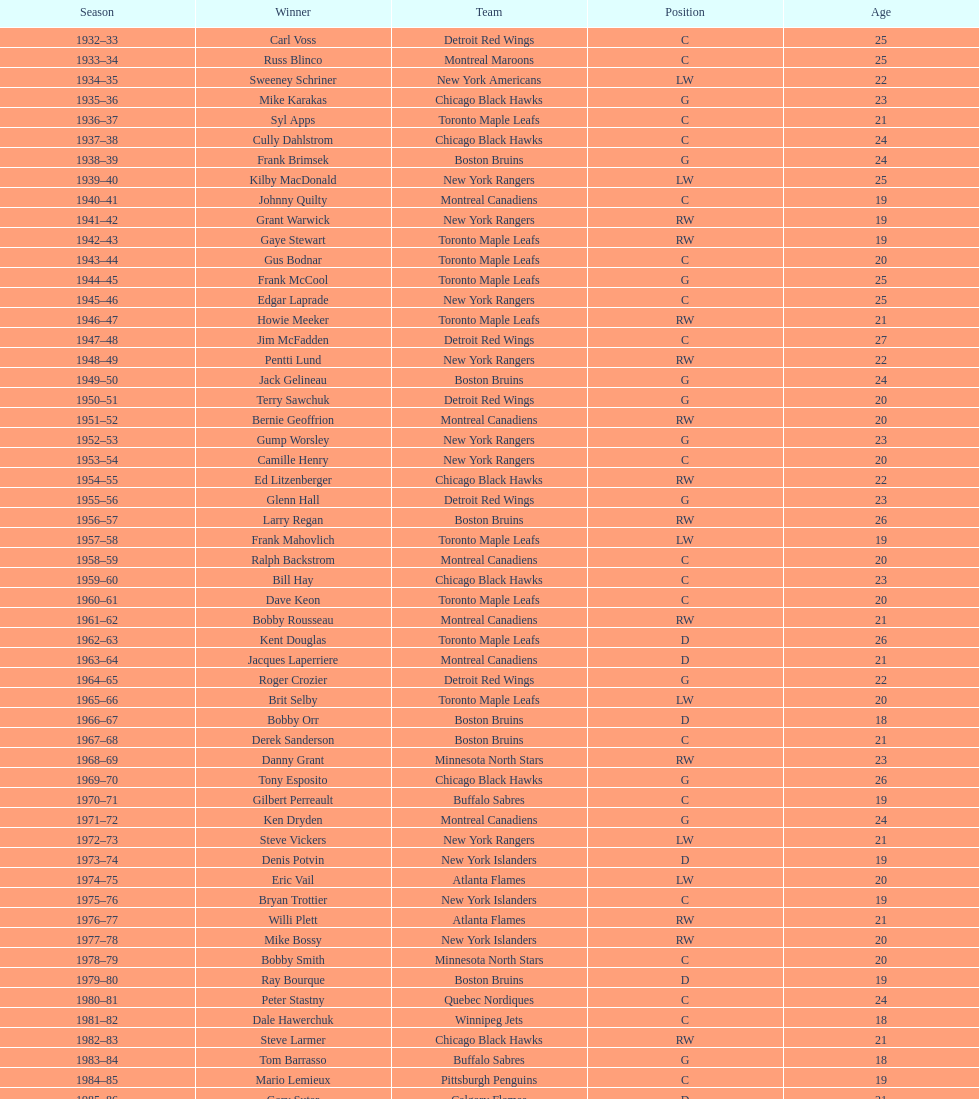Could you parse the entire table as a dict? {'header': ['Season', 'Winner', 'Team', 'Position', 'Age'], 'rows': [['1932–33', 'Carl Voss', 'Detroit Red Wings', 'C', '25'], ['1933–34', 'Russ Blinco', 'Montreal Maroons', 'C', '25'], ['1934–35', 'Sweeney Schriner', 'New York Americans', 'LW', '22'], ['1935–36', 'Mike Karakas', 'Chicago Black Hawks', 'G', '23'], ['1936–37', 'Syl Apps', 'Toronto Maple Leafs', 'C', '21'], ['1937–38', 'Cully Dahlstrom', 'Chicago Black Hawks', 'C', '24'], ['1938–39', 'Frank Brimsek', 'Boston Bruins', 'G', '24'], ['1939–40', 'Kilby MacDonald', 'New York Rangers', 'LW', '25'], ['1940–41', 'Johnny Quilty', 'Montreal Canadiens', 'C', '19'], ['1941–42', 'Grant Warwick', 'New York Rangers', 'RW', '19'], ['1942–43', 'Gaye Stewart', 'Toronto Maple Leafs', 'RW', '19'], ['1943–44', 'Gus Bodnar', 'Toronto Maple Leafs', 'C', '20'], ['1944–45', 'Frank McCool', 'Toronto Maple Leafs', 'G', '25'], ['1945–46', 'Edgar Laprade', 'New York Rangers', 'C', '25'], ['1946–47', 'Howie Meeker', 'Toronto Maple Leafs', 'RW', '21'], ['1947–48', 'Jim McFadden', 'Detroit Red Wings', 'C', '27'], ['1948–49', 'Pentti Lund', 'New York Rangers', 'RW', '22'], ['1949–50', 'Jack Gelineau', 'Boston Bruins', 'G', '24'], ['1950–51', 'Terry Sawchuk', 'Detroit Red Wings', 'G', '20'], ['1951–52', 'Bernie Geoffrion', 'Montreal Canadiens', 'RW', '20'], ['1952–53', 'Gump Worsley', 'New York Rangers', 'G', '23'], ['1953–54', 'Camille Henry', 'New York Rangers', 'C', '20'], ['1954–55', 'Ed Litzenberger', 'Chicago Black Hawks', 'RW', '22'], ['1955–56', 'Glenn Hall', 'Detroit Red Wings', 'G', '23'], ['1956–57', 'Larry Regan', 'Boston Bruins', 'RW', '26'], ['1957–58', 'Frank Mahovlich', 'Toronto Maple Leafs', 'LW', '19'], ['1958–59', 'Ralph Backstrom', 'Montreal Canadiens', 'C', '20'], ['1959–60', 'Bill Hay', 'Chicago Black Hawks', 'C', '23'], ['1960–61', 'Dave Keon', 'Toronto Maple Leafs', 'C', '20'], ['1961–62', 'Bobby Rousseau', 'Montreal Canadiens', 'RW', '21'], ['1962–63', 'Kent Douglas', 'Toronto Maple Leafs', 'D', '26'], ['1963–64', 'Jacques Laperriere', 'Montreal Canadiens', 'D', '21'], ['1964–65', 'Roger Crozier', 'Detroit Red Wings', 'G', '22'], ['1965–66', 'Brit Selby', 'Toronto Maple Leafs', 'LW', '20'], ['1966–67', 'Bobby Orr', 'Boston Bruins', 'D', '18'], ['1967–68', 'Derek Sanderson', 'Boston Bruins', 'C', '21'], ['1968–69', 'Danny Grant', 'Minnesota North Stars', 'RW', '23'], ['1969–70', 'Tony Esposito', 'Chicago Black Hawks', 'G', '26'], ['1970–71', 'Gilbert Perreault', 'Buffalo Sabres', 'C', '19'], ['1971–72', 'Ken Dryden', 'Montreal Canadiens', 'G', '24'], ['1972–73', 'Steve Vickers', 'New York Rangers', 'LW', '21'], ['1973–74', 'Denis Potvin', 'New York Islanders', 'D', '19'], ['1974–75', 'Eric Vail', 'Atlanta Flames', 'LW', '20'], ['1975–76', 'Bryan Trottier', 'New York Islanders', 'C', '19'], ['1976–77', 'Willi Plett', 'Atlanta Flames', 'RW', '21'], ['1977–78', 'Mike Bossy', 'New York Islanders', 'RW', '20'], ['1978–79', 'Bobby Smith', 'Minnesota North Stars', 'C', '20'], ['1979–80', 'Ray Bourque', 'Boston Bruins', 'D', '19'], ['1980–81', 'Peter Stastny', 'Quebec Nordiques', 'C', '24'], ['1981–82', 'Dale Hawerchuk', 'Winnipeg Jets', 'C', '18'], ['1982–83', 'Steve Larmer', 'Chicago Black Hawks', 'RW', '21'], ['1983–84', 'Tom Barrasso', 'Buffalo Sabres', 'G', '18'], ['1984–85', 'Mario Lemieux', 'Pittsburgh Penguins', 'C', '19'], ['1985–86', 'Gary Suter', 'Calgary Flames', 'D', '21'], ['1986–87', 'Luc Robitaille', 'Los Angeles Kings', 'LW', '20'], ['1987–88', 'Joe Nieuwendyk', 'Calgary Flames', 'C', '21'], ['1988–89', 'Brian Leetch', 'New York Rangers', 'D', '20'], ['1989–90', 'Sergei Makarov', 'Calgary Flames', 'RW', '31'], ['1990–91', 'Ed Belfour', 'Chicago Blackhawks', 'G', '25'], ['1991–92', 'Pavel Bure', 'Vancouver Canucks', 'RW', '20'], ['1992–93', 'Teemu Selanne', 'Winnipeg Jets', 'RW', '22'], ['1993–94', 'Martin Brodeur', 'New Jersey Devils', 'G', '21'], ['1994–95', 'Peter Forsberg', 'Quebec Nordiques', 'C', '21'], ['1995–96', 'Daniel Alfredsson', 'Ottawa Senators', 'RW', '22'], ['1996–97', 'Bryan Berard', 'New York Islanders', 'D', '19'], ['1997–98', 'Sergei Samsonov', 'Boston Bruins', 'LW', '19'], ['1998–99', 'Chris Drury', 'Colorado Avalanche', 'C', '22'], ['1999–2000', 'Scott Gomez', 'New Jersey Devils', 'C', '19'], ['2000–01', 'Evgeni Nabokov', 'San Jose Sharks', 'G', '25'], ['2001–02', 'Dany Heatley', 'Atlanta Thrashers', 'RW', '20'], ['2002–03', 'Barret Jackman', 'St. Louis Blues', 'D', '21'], ['2003–04', 'Andrew Raycroft', 'Boston Bruins', 'G', '23'], ['2004–05', 'No winner because of the\\n2004–05 NHL lockout', '-', '-', '-'], ['2005–06', 'Alexander Ovechkin', 'Washington Capitals', 'LW', '20'], ['2006–07', 'Evgeni Malkin', 'Pittsburgh Penguins', 'C', '20'], ['2007–08', 'Patrick Kane', 'Chicago Blackhawks', 'RW', '19'], ['2008–09', 'Steve Mason', 'Columbus Blue Jackets', 'G', '21'], ['2009–10', 'Tyler Myers', 'Buffalo Sabres', 'D', '20'], ['2010–11', 'Jeff Skinner', 'Carolina Hurricanes', 'C', '18'], ['2011–12', 'Gabriel Landeskog', 'Colorado Avalanche', 'LW', '19'], ['2012–13', 'Jonathan Huberdeau', 'Florida Panthers', 'C', '19']]} What is the total number of victories for the toronto maple leafs? 9. 